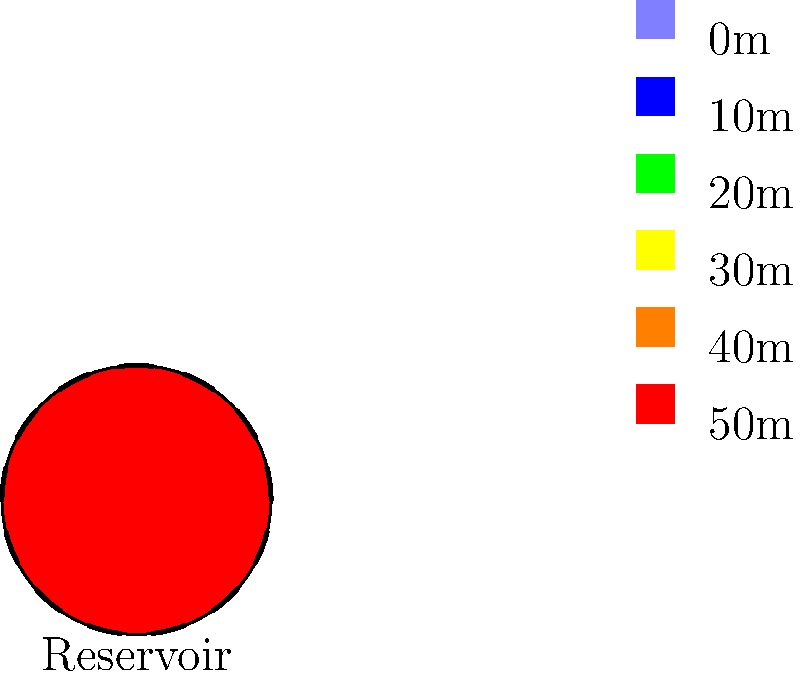As a nostalgic app developer who appreciates simplicity, you're tasked with creating an app to determine the optimal shape of a water reservoir. Given the topographical contours shown in the image, what shape would you recommend for the reservoir to maximize water storage while minimizing construction costs? To determine the optimal shape of the water reservoir, we need to consider both water storage capacity and construction costs. Let's break it down step-by-step:

1. Observe the contour lines: The contours are concentric circles, indicating a symmetrical hill or depression.

2. Analyze the topography: The elevation increases from the center outwards, suggesting a bowl-shaped depression.

3. Consider water storage:
   a. A reservoir following the natural contours will maximize water storage.
   b. Water naturally settles into a level surface due to gravity.

4. Evaluate construction costs:
   a. A simple shape is easier and cheaper to construct.
   b. Following natural contours reduces the need for extensive excavation.

5. Balance storage and cost:
   a. A circular shape matches the contours perfectly.
   b. It provides maximum volume for a given perimeter (isoperimetric property).
   c. A circle is the simplest shape to design and construct.

6. Consider dam placement:
   a. A single, straight dam section can be used to close off the circular reservoir.
   b. This minimizes dam length and construction costs.

7. Optimal solution:
   The dashed line in the image shows the ideal circular shape, following the natural contours while maximizing storage and minimizing costs.

In the spirit of simplicity that resonates with earlier iOS versions, a circular reservoir shape offers an elegant, efficient, and cost-effective solution.
Answer: Circular shape 